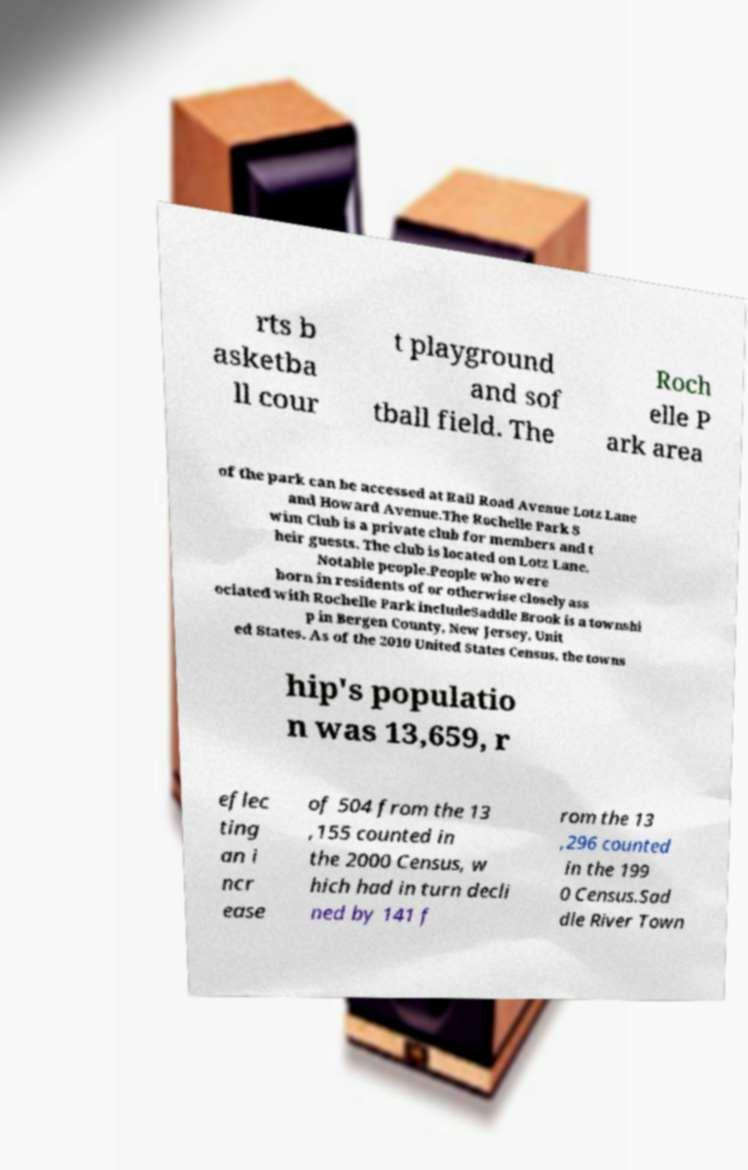There's text embedded in this image that I need extracted. Can you transcribe it verbatim? rts b asketba ll cour t playground and sof tball field. The Roch elle P ark area of the park can be accessed at Rail Road Avenue Lotz Lane and Howard Avenue.The Rochelle Park S wim Club is a private club for members and t heir guests. The club is located on Lotz Lane. Notable people.People who were born in residents of or otherwise closely ass ociated with Rochelle Park includeSaddle Brook is a townshi p in Bergen County, New Jersey, Unit ed States. As of the 2010 United States Census, the towns hip's populatio n was 13,659, r eflec ting an i ncr ease of 504 from the 13 ,155 counted in the 2000 Census, w hich had in turn decli ned by 141 f rom the 13 ,296 counted in the 199 0 Census.Sad dle River Town 